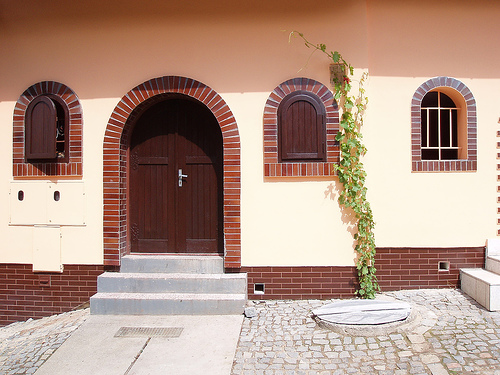<image>
Can you confirm if the ivy is on the house? Yes. Looking at the image, I can see the ivy is positioned on top of the house, with the house providing support. 